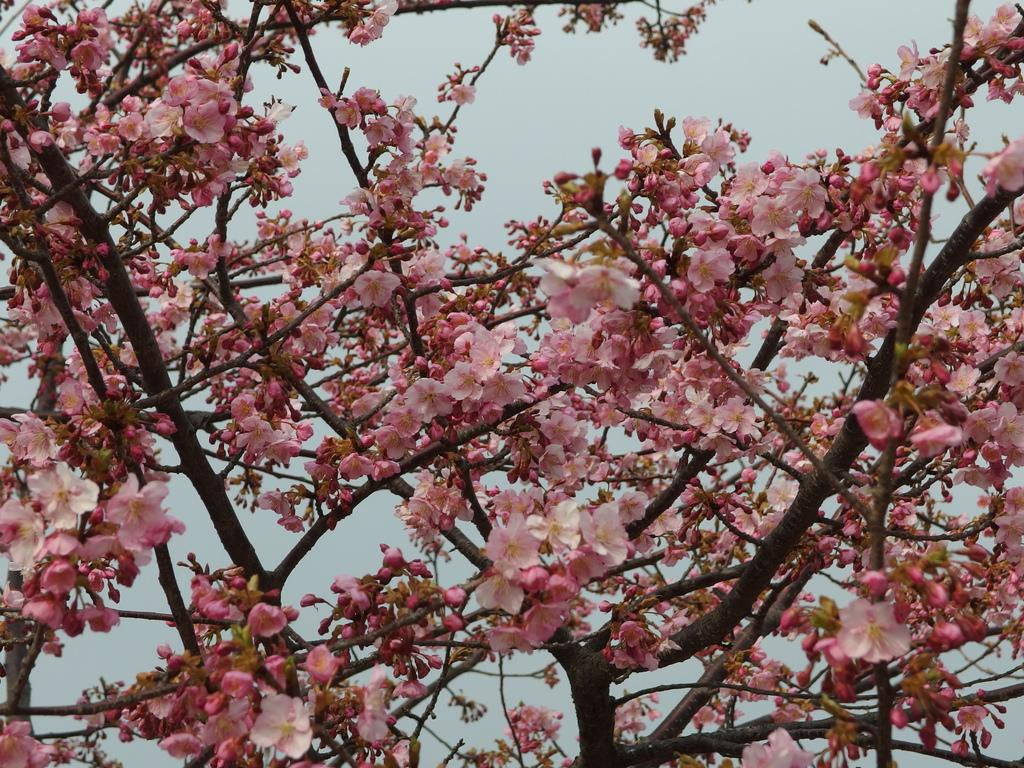What is present on the branches of the tree in the image? There is a group of flowers on the branches of a tree in the image. What can be seen in the background of the image? The sky is visible in the background of the image. How many dimes can be seen on the branches of the tree in the image? There are no dimes present on the branches of the tree in the image. What type of glove is being used to push the flowers off the tree in the image? There is no glove or pushing action present in the image; the flowers are naturally on the tree branches. 